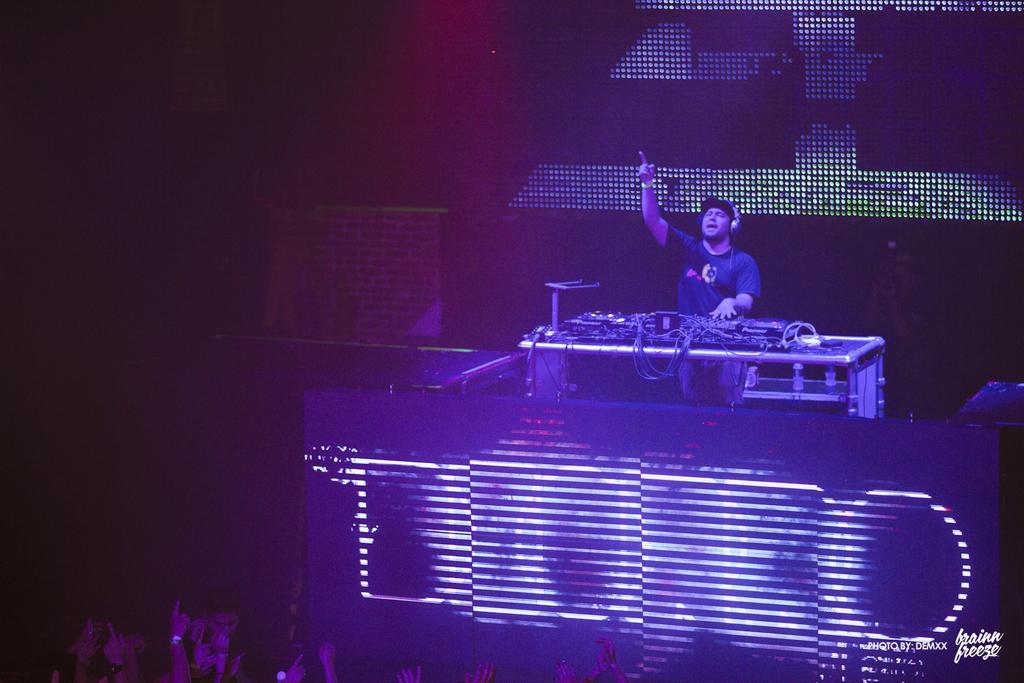Please provide a concise description of this image. It is a concert,there is a man playing music,he is wearing a headset and there are some LED lights in front of the man and and the crowd is enjoying the music. 